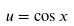<formula> <loc_0><loc_0><loc_500><loc_500>u = \cos x</formula> 